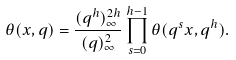Convert formula to latex. <formula><loc_0><loc_0><loc_500><loc_500>\theta ( x , q ) = \frac { ( q ^ { h } ) _ { \infty } ^ { 2 h } } { ( q ) _ { \infty } ^ { 2 } } \prod _ { s = 0 } ^ { h - 1 } \theta ( q ^ { s } x , q ^ { h } ) .</formula> 